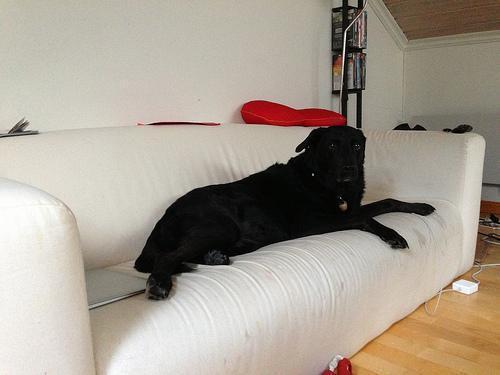How many dogs are in the picture?
Give a very brief answer. 1. 